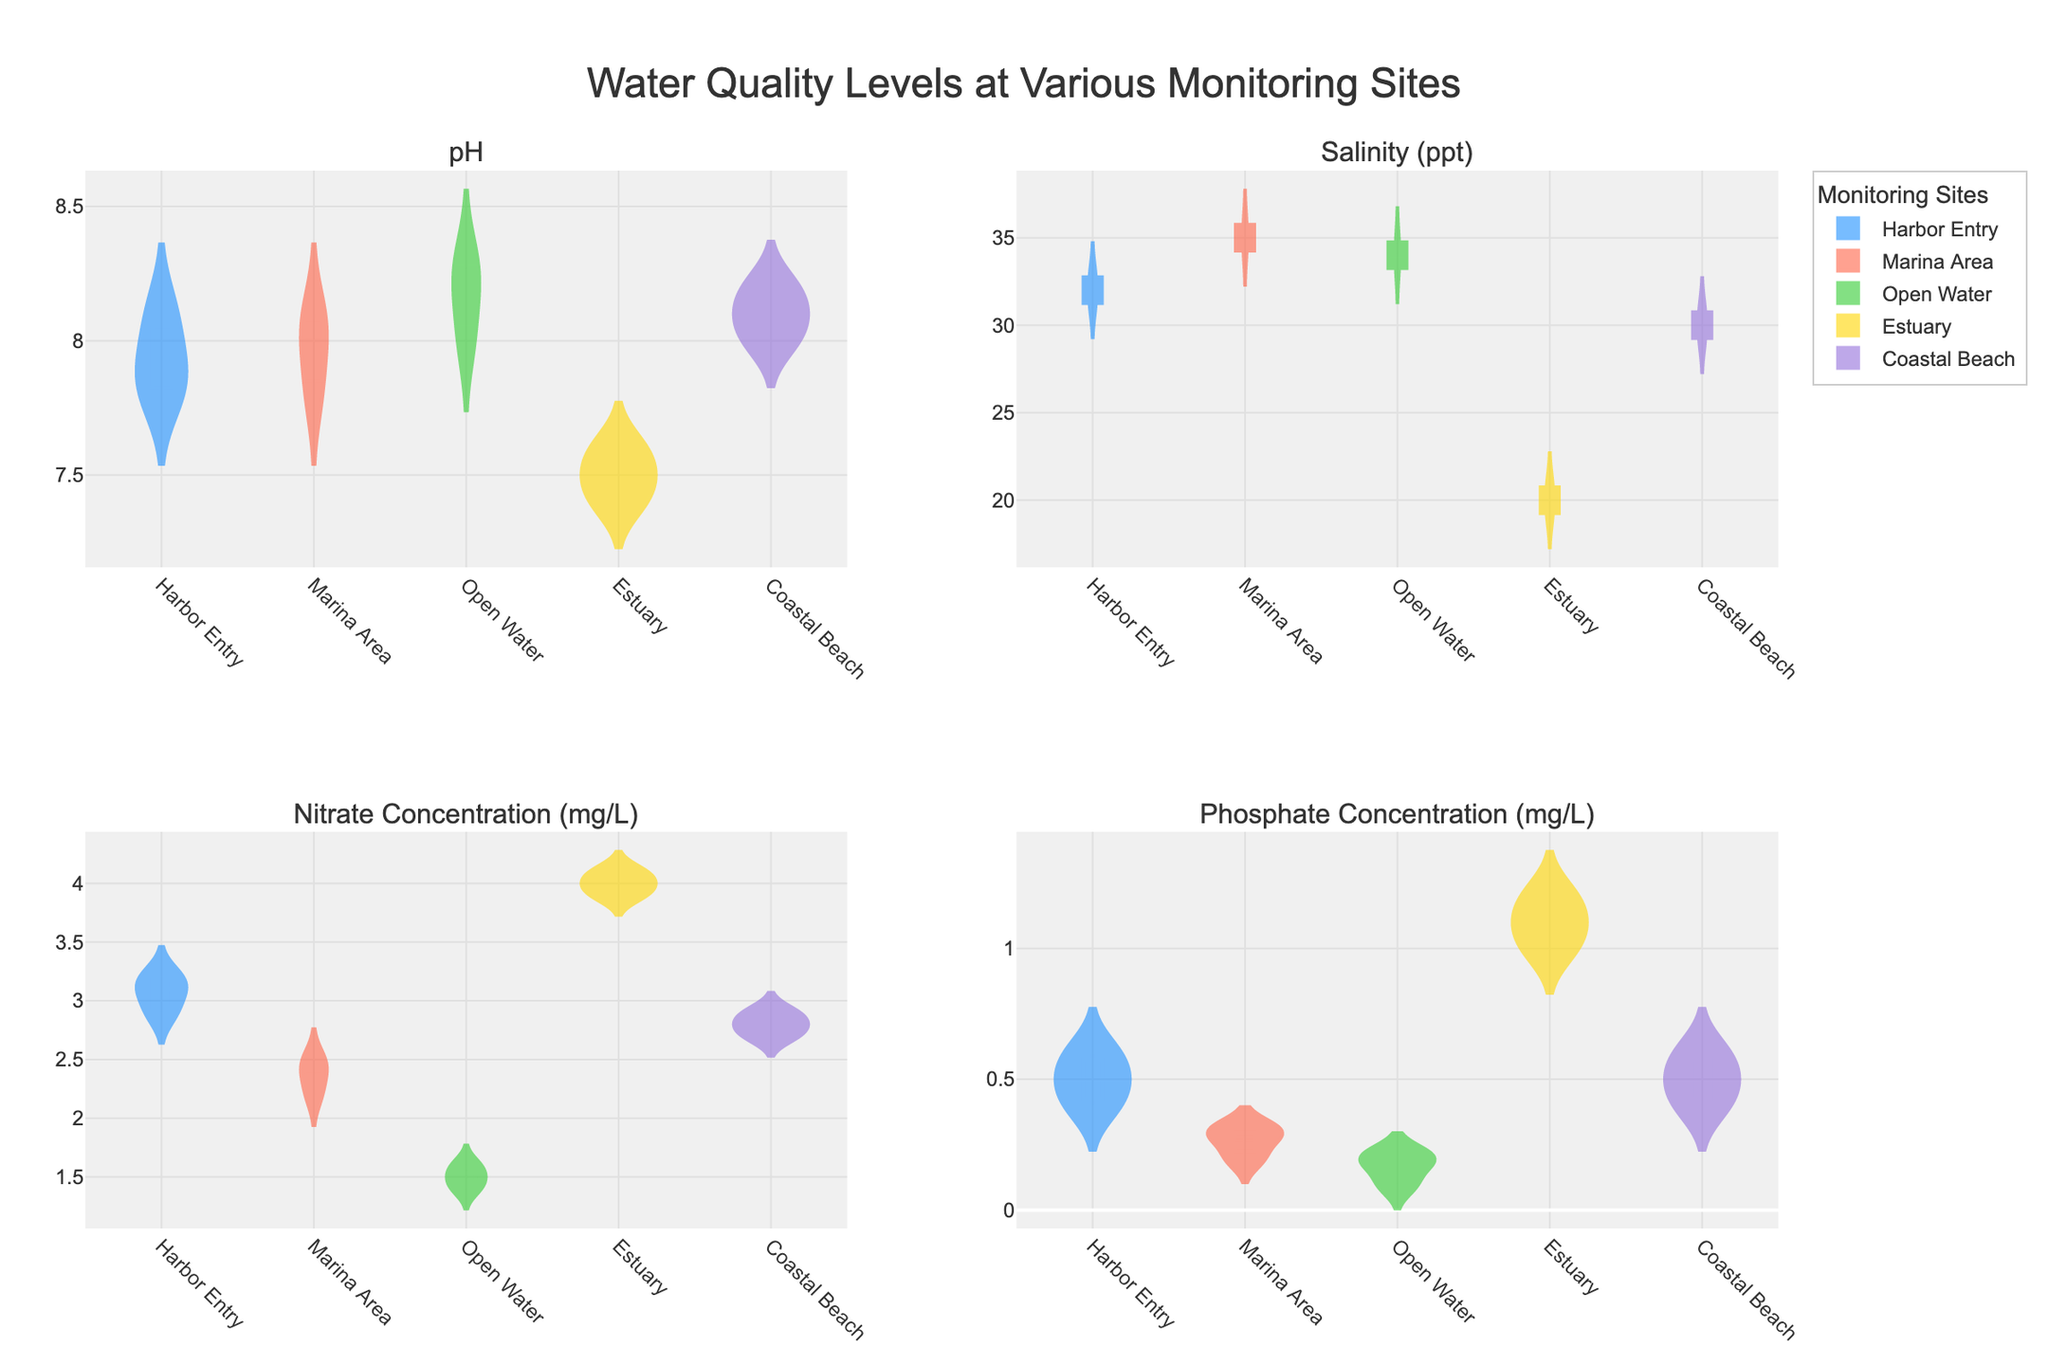Which monitoring site has the highest median pH level? By looking at the violin plots for pH levels, identify the medians represented by horizontal lines across the violin plots. Compare the median lines for each site.
Answer: Open Water What is the overall pH range observed across all monitoring sites? Observe the vertical spans of the violin plots for pH levels for all sites and note the minimum and maximum values.
Answer: 7.4 to 8.3 Which monitoring site has the most variable (widest range) salinity levels? The variability can be seen by the span of the violin plot for each site. Compare the ranges vertically for each site’s salinity plot.
Answer: Marina Area Comparing Nitrate Concentration (mg/L), which site has the lowest median value and which has the highest? Look at the Nitrate Concentration violin plots and identify the median lines. Compare them visually.
Answer: Lowest: Open Water, Highest: Estuary What is the average median Phosphate Concentration (mg/L) across all monitoring sites? Identify and sum the median values for each site in the Phosphate Concentration violin plots, then divide by the number of sites. Estimation based on visual inspection works.
Answer: (0.5 + 0.3 + 0.2 + 1.1 + 0.5)/5 = 0.52 How does the median salinity level in the Marina Area compare to that in the Harbor Entry? Identify the median salinity levels in the Marina Area and Harbor Entry violin plots, then compare the two.
Answer: Marina Area is higher Which monitoring site shows signs of potential pollution based on higher Nitrate Concentration levels? Examine the violin plots for Nitrate Concentration to find the site with typically higher values. High nitrate indicates potential pollution.
Answer: Estuary What is the median pH level at the Coastal Beach site? Look at the Coastal Beach pH violin plot and identify the median horizontal line.
Answer: 8.1 Which parameter shows the least variation across monitoring sites? Compare the spans of the violin plots for each parameter across all sites to judge which has the smallest range.
Answer: pH Is there a monitoring site where the Phosphate Concentration is generally below 0.5 mg/L? Look at the Phosphate Concentration violin plots and observe which sites have most of the data below 0.5 mg/L.
Answer: Marina Area 